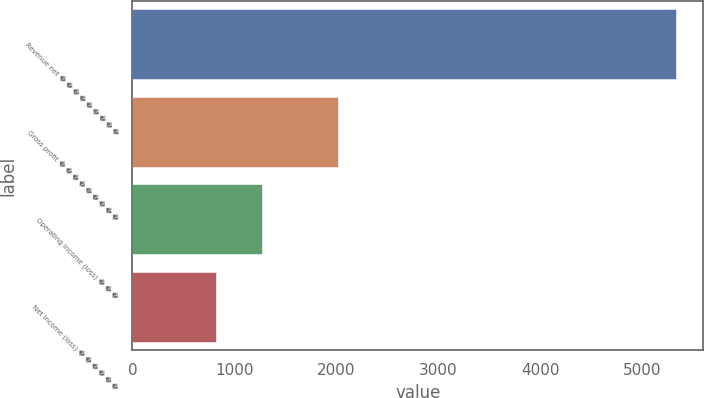Convert chart to OTSL. <chart><loc_0><loc_0><loc_500><loc_500><bar_chart><fcel>Revenue net � � � � � � � � �<fcel>Gross profit � � � � � � � � �<fcel>Operating income (loss) � � �<fcel>Net income (loss) � � � � � �<nl><fcel>5336<fcel>2013<fcel>1274.3<fcel>823<nl></chart> 